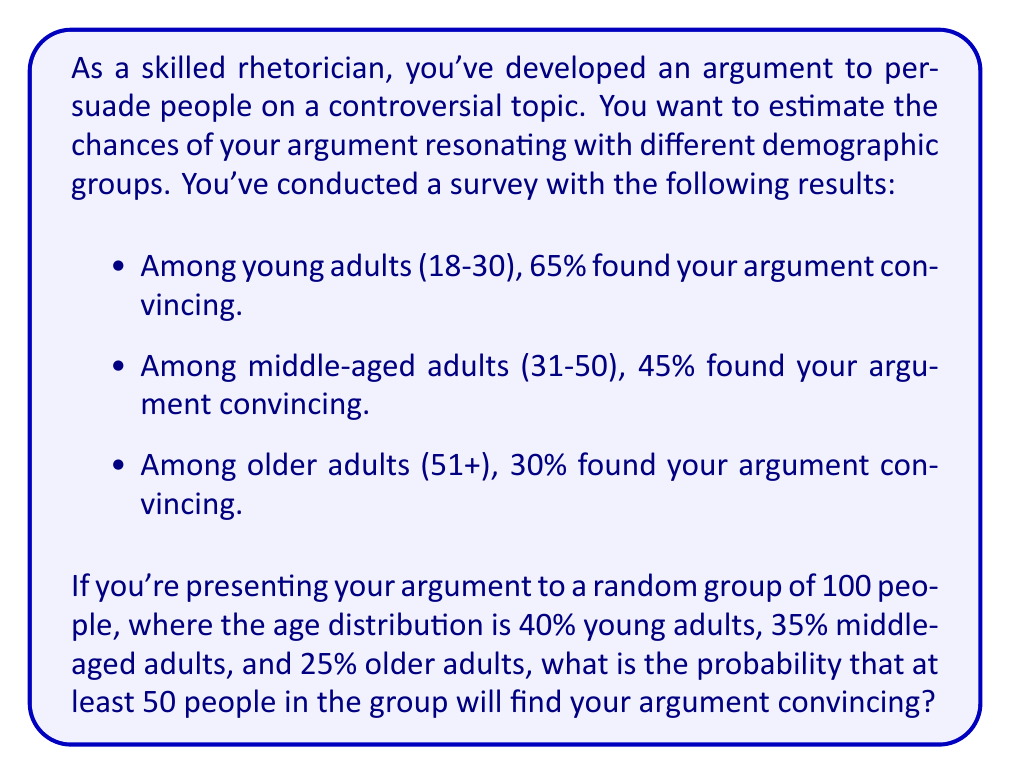Provide a solution to this math problem. To solve this problem, we'll use the binomial probability distribution and the concept of expected value.

1. First, let's calculate the overall probability of a random person finding the argument convincing:

   $P(\text{convincing}) = 0.40 \cdot 0.65 + 0.35 \cdot 0.45 + 0.25 \cdot 0.30 = 0.4925$

2. Now, we can treat this as a binomial probability problem with:
   $n = 100$ (total people)
   $p = 0.4925$ (probability of success)
   
3. We want to find the probability of at least 50 successes, which is equivalent to 1 minus the probability of 49 or fewer successes:

   $P(X \geq 50) = 1 - P(X \leq 49)$

4. We can use the cumulative binomial probability function to calculate this:

   $P(X \geq 50) = 1 - \sum_{k=0}^{49} \binom{100}{k} p^k (1-p)^{100-k}$

5. This calculation is complex to do by hand, so we would typically use software or a calculator with a built-in binomial cumulative distribution function.

6. Using such a tool, we find:

   $P(X \geq 50) = 1 - P(X \leq 49) \approx 1 - 0.4761 = 0.5239$

Therefore, the probability that at least 50 people in the group will find your argument convincing is approximately 0.5239 or 52.39%.
Answer: The probability that at least 50 people in the group of 100 will find the argument convincing is approximately 0.5239 or 52.39%. 